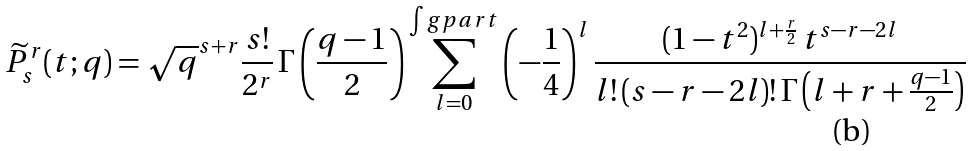<formula> <loc_0><loc_0><loc_500><loc_500>\widetilde { P } _ { s } ^ { r } ( t ; q ) = \sqrt { q } ^ { s + r } \frac { s ! } { 2 ^ { r } } \, \Gamma \left ( \frac { q - 1 } { 2 } \right ) \sum _ { l = 0 } ^ { \int g p a r t } \left ( - \frac { 1 } { 4 } \right ) ^ { l } \frac { ( 1 - t ^ { 2 } ) ^ { l + \frac { r } { 2 } } \, t ^ { s - r - 2 l } } { l ! \, ( s - r - 2 l ) ! \, \Gamma \left ( l + r + \frac { q - 1 } { 2 } \right ) }</formula> 